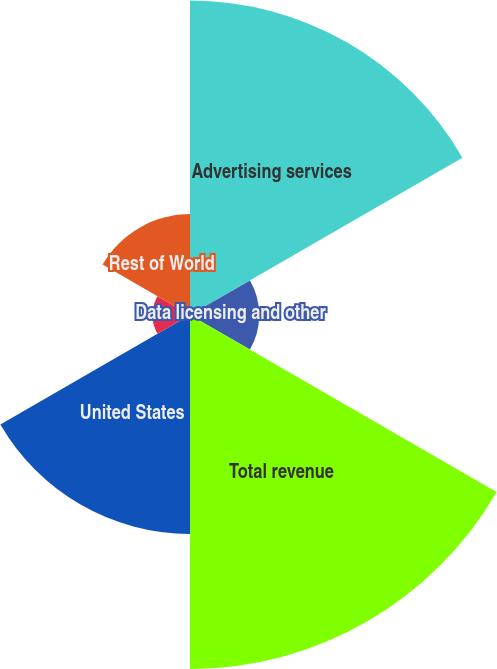Convert chart. <chart><loc_0><loc_0><loc_500><loc_500><pie_chart><fcel>Advertising services<fcel>Data licensing and other<fcel>Total revenue<fcel>United States<fcel>Japan<fcel>Rest of World<nl><fcel>28.72%<fcel>6.32%<fcel>32.32%<fcel>19.99%<fcel>3.43%<fcel>9.21%<nl></chart> 